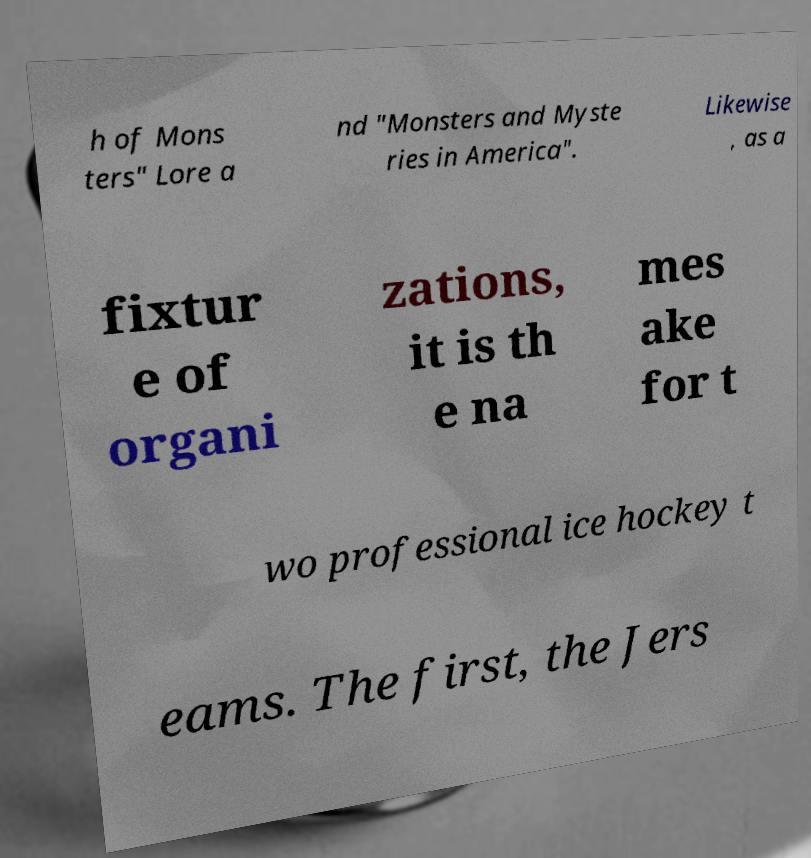Could you extract and type out the text from this image? h of Mons ters" Lore a nd "Monsters and Myste ries in America". Likewise , as a fixtur e of organi zations, it is th e na mes ake for t wo professional ice hockey t eams. The first, the Jers 